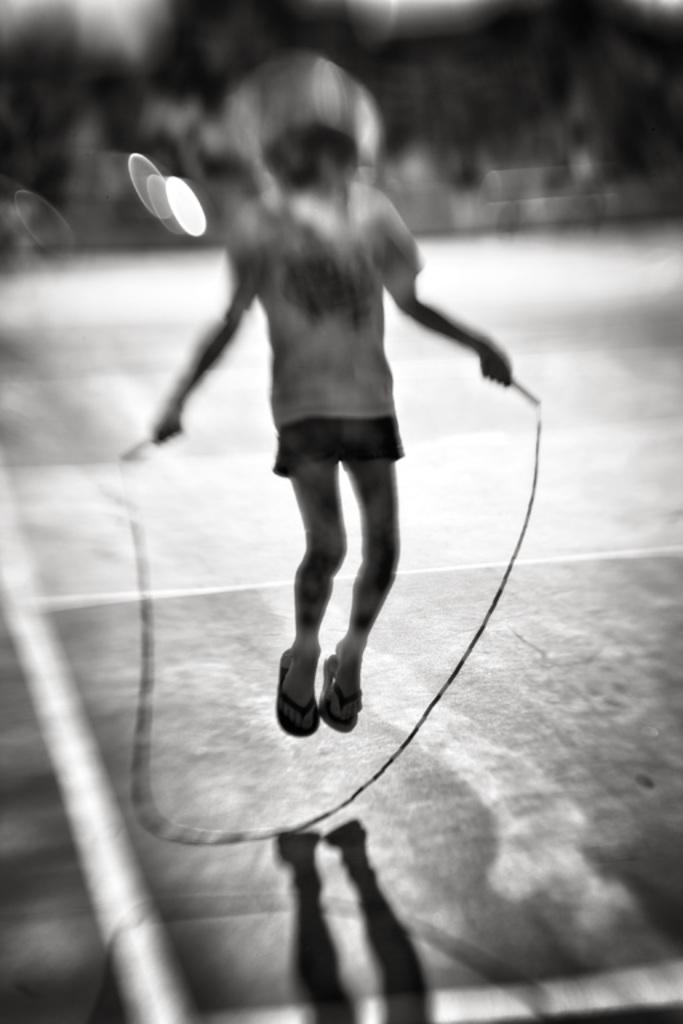What is the color scheme of the image? The image is black and white. What is the main subject in the image? There is a person in the center of the image. What is the person doing in the image? The person is slipping on the ground. What type of wind can be seen blowing in the image? There is no wind present in the image, as it is a black and white image of a person slipping on the ground. 